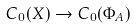<formula> <loc_0><loc_0><loc_500><loc_500>C _ { 0 } ( X ) \rightarrow C _ { 0 } ( \Phi _ { A } )</formula> 